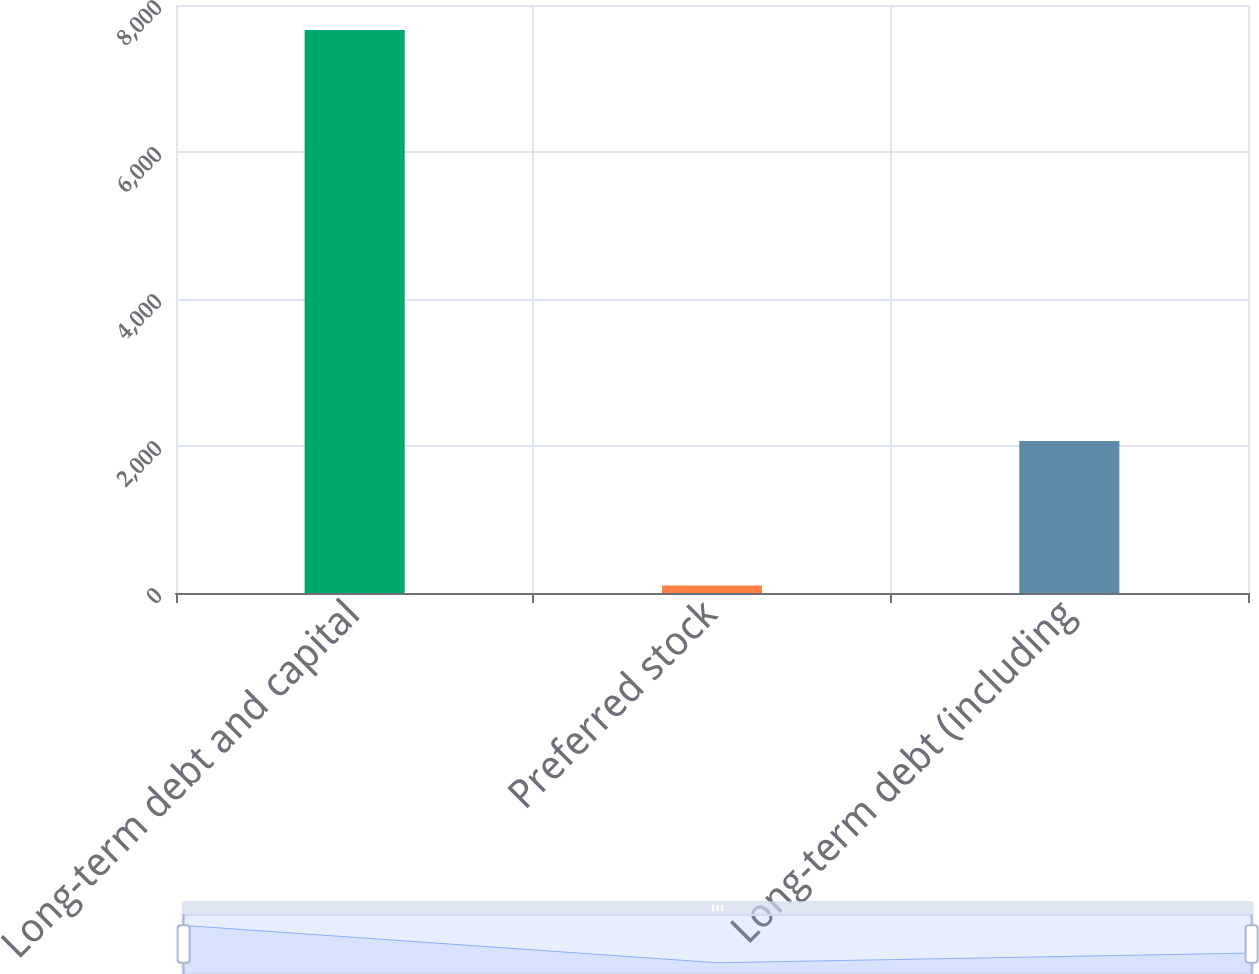Convert chart to OTSL. <chart><loc_0><loc_0><loc_500><loc_500><bar_chart><fcel>Long-term debt and capital<fcel>Preferred stock<fcel>Long-term debt (including<nl><fcel>7661<fcel>102<fcel>2067<nl></chart> 